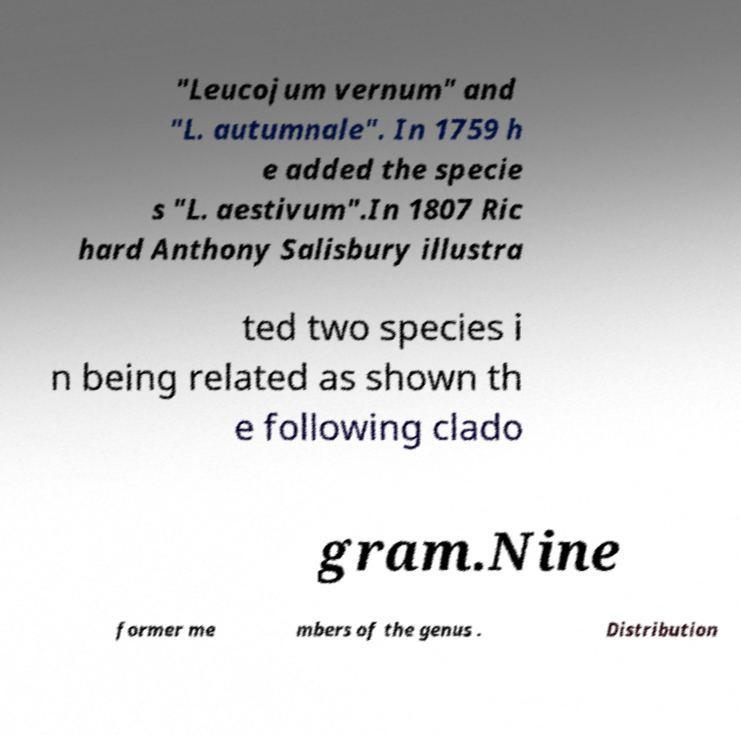Please identify and transcribe the text found in this image. "Leucojum vernum" and "L. autumnale". In 1759 h e added the specie s "L. aestivum".In 1807 Ric hard Anthony Salisbury illustra ted two species i n being related as shown th e following clado gram.Nine former me mbers of the genus . Distribution 